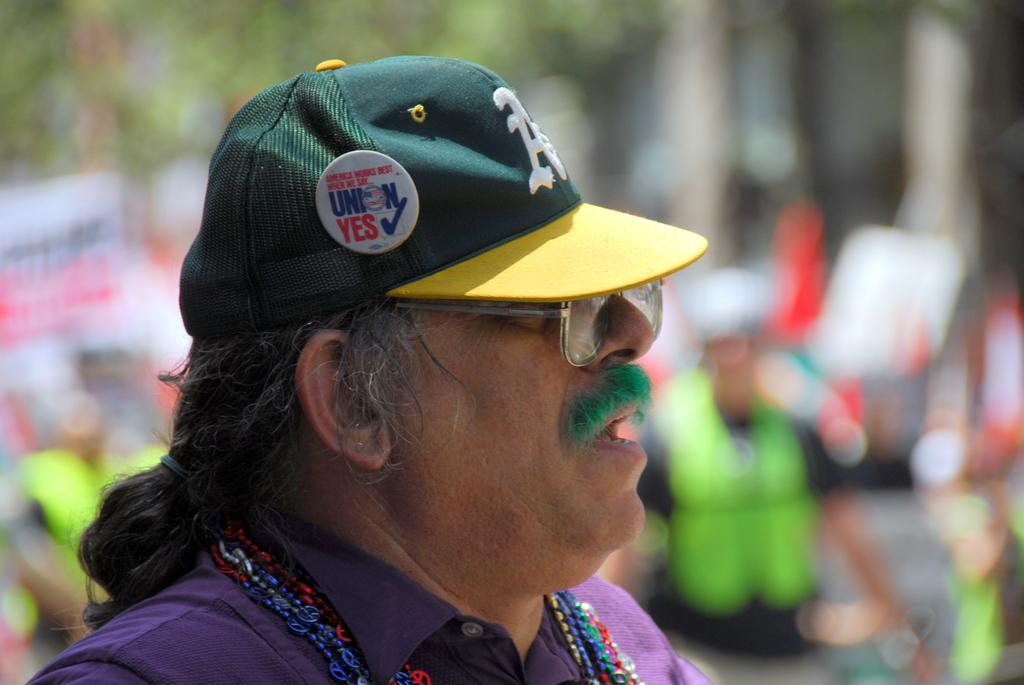What can be seen in the image? There is a person in the image. Can you describe the person's appearance? The person is wearing glasses and a cap. What is the background of the image like? The background of the image has a blurred view. Are there any other people visible in the image? Yes, there are other people visible in the image. What type of nut is being served by the person in the image? There is no nut being served in the image, nor is there any indication of a servant present. 